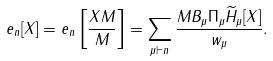<formula> <loc_0><loc_0><loc_500><loc_500>e _ { n } [ X ] = e _ { n } \left [ \frac { X M } { M } \right ] = \sum _ { \mu \vdash n } \frac { M B _ { \mu } \Pi _ { \mu } \widetilde { H } _ { \mu } [ X ] } { w _ { \mu } } .</formula> 